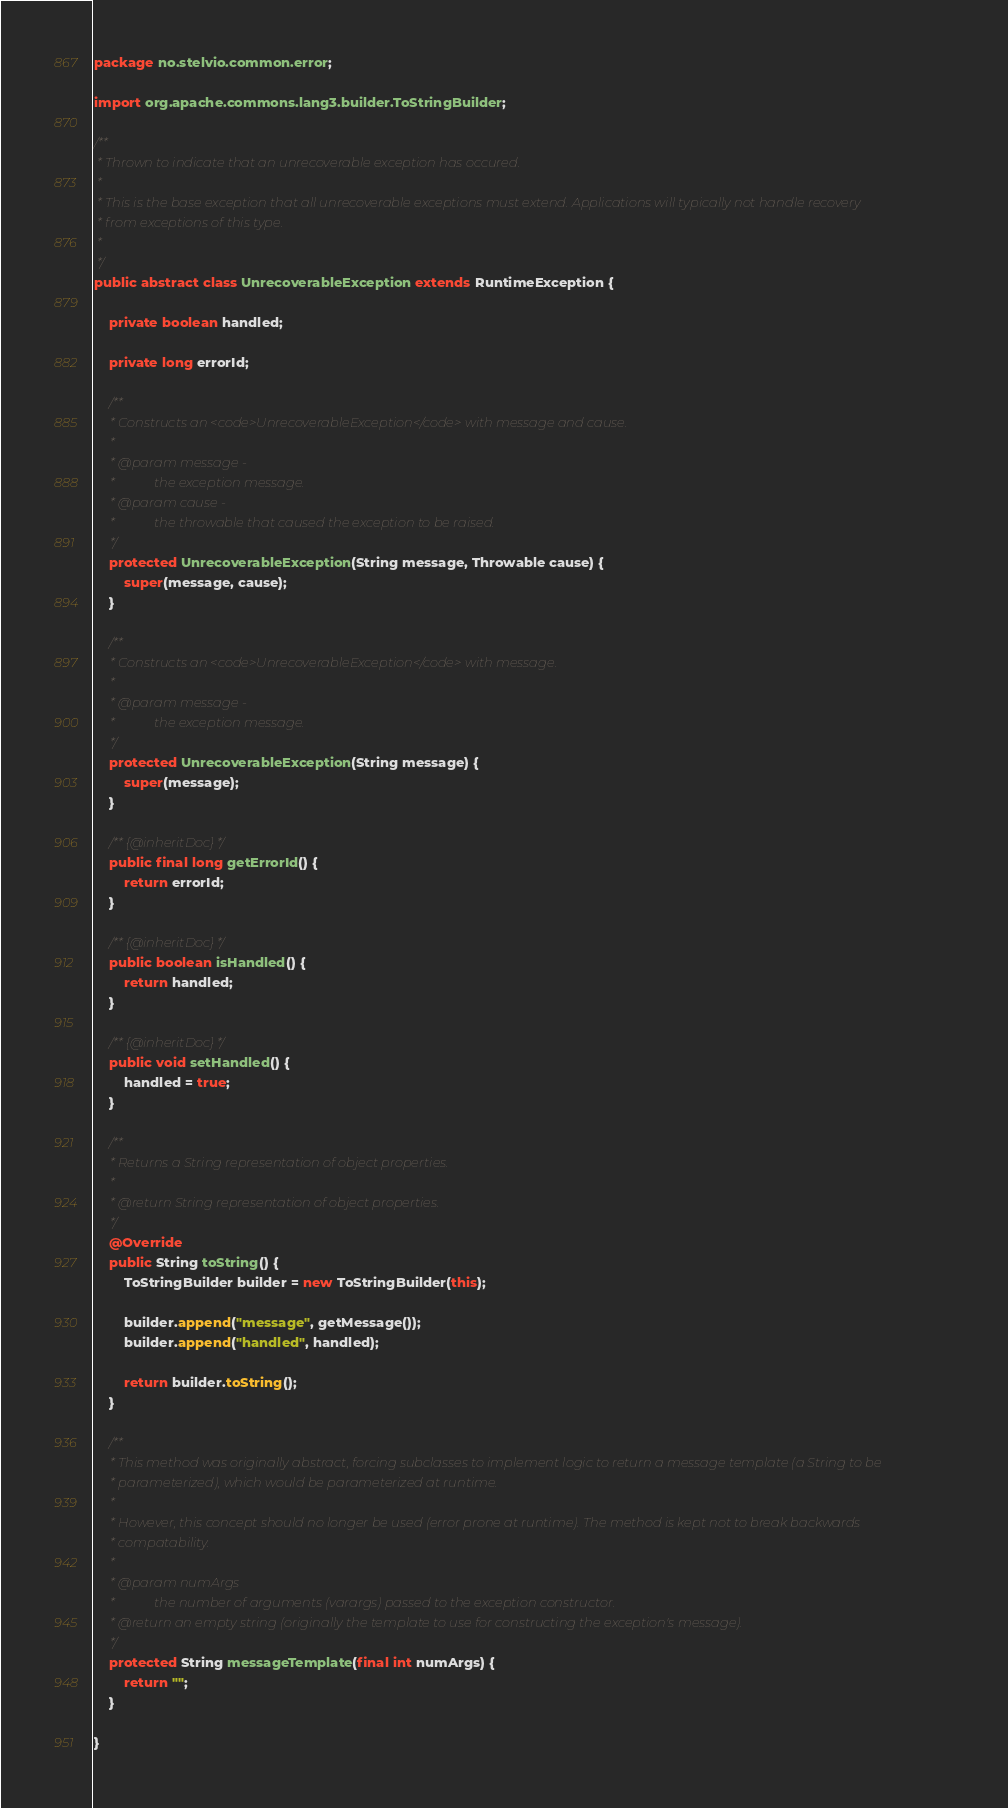Convert code to text. <code><loc_0><loc_0><loc_500><loc_500><_Java_>package no.stelvio.common.error;

import org.apache.commons.lang3.builder.ToStringBuilder;

/**
 * Thrown to indicate that an unrecoverable exception has occured.
 * 
 * This is the base exception that all unrecoverable exceptions must extend. Applications will typically not handle recovery
 * from exceptions of this type.
 * 
 */
public abstract class UnrecoverableException extends RuntimeException {

	private boolean handled;

	private long errorId;

	/**
	 * Constructs an <code>UnrecoverableException</code> with message and cause.
	 * 
	 * @param message -
	 *            the exception message.
	 * @param cause -
	 *            the throwable that caused the exception to be raised.
	 */
	protected UnrecoverableException(String message, Throwable cause) {
		super(message, cause);
	}

	/**
	 * Constructs an <code>UnrecoverableException</code> with message.
	 * 
	 * @param message -
	 *            the exception message.
	 */
	protected UnrecoverableException(String message) {
		super(message);
	}

	/** {@inheritDoc} */
	public final long getErrorId() {
		return errorId;
	}

	/** {@inheritDoc} */
	public boolean isHandled() {
		return handled;
	}

	/** {@inheritDoc} */
	public void setHandled() {
		handled = true;
	}

	/**
	 * Returns a String representation of object properties.
	 * 
	 * @return String representation of object properties.
	 */
	@Override
	public String toString() {
		ToStringBuilder builder = new ToStringBuilder(this);

		builder.append("message", getMessage());
		builder.append("handled", handled);

		return builder.toString();
	}

	/**
	 * This method was originally abstract, forcing subclasses to implement logic to return a message template (a String to be
	 * parameterized), which would be parameterized at runtime.
	 * 
	 * However, this concept should no longer be used (error prone at runtime). The method is kept not to break backwards
	 * compatability.
	 * 
	 * @param numArgs
	 *            the number of arguments (varargs) passed to the exception constructor.
	 * @return an empty string (originally the template to use for constructing the exception's message).
	 */
	protected String messageTemplate(final int numArgs) {
		return "";
	}

}</code> 